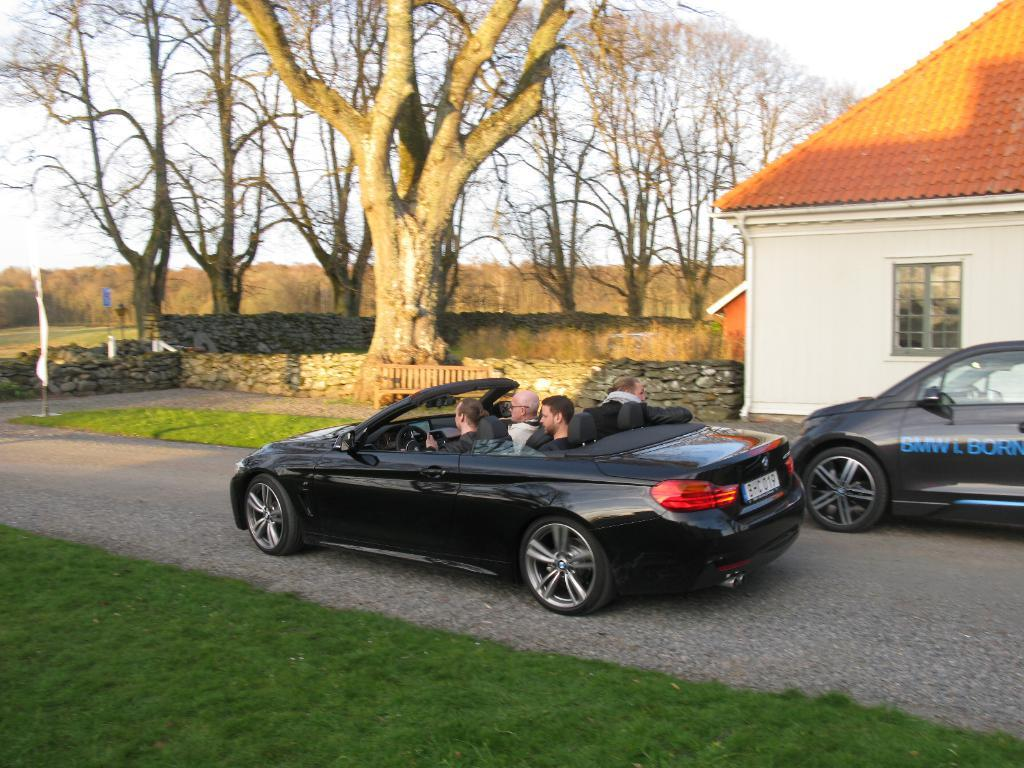What are the people in the image doing? The people in the image are sitting in a car. What else can be seen on the road in the image? There are cars on the road. What type of vegetation is visible in the image? There is grass visible in the image. What type of structure is present in the image? There is a house in the image. What type of outdoor furniture is present in the image? There is a bench in the image. What can be seen in the background of the image? There are trees, a wall, plants, and the sky visible in the background of the image. What type of test can be seen being conducted on the bench in the image? There is no test being conducted on the bench in the image. What type of cushion is used to make the bench more comfortable in the image? There is no cushion mentioned or visible on the bench in the image. 